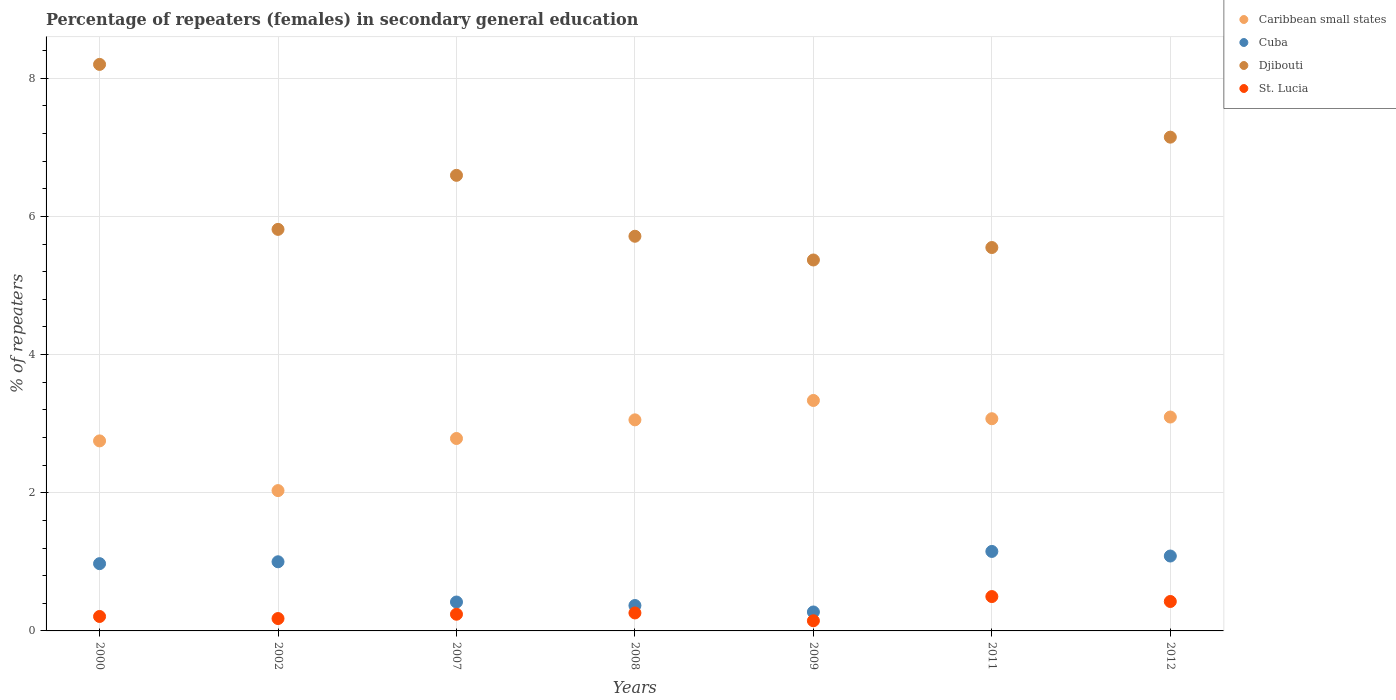Is the number of dotlines equal to the number of legend labels?
Provide a short and direct response. Yes. What is the percentage of female repeaters in St. Lucia in 2011?
Provide a succinct answer. 0.5. Across all years, what is the maximum percentage of female repeaters in Cuba?
Ensure brevity in your answer.  1.15. Across all years, what is the minimum percentage of female repeaters in Caribbean small states?
Give a very brief answer. 2.03. In which year was the percentage of female repeaters in Djibouti maximum?
Your response must be concise. 2000. In which year was the percentage of female repeaters in Djibouti minimum?
Your answer should be compact. 2009. What is the total percentage of female repeaters in Caribbean small states in the graph?
Your response must be concise. 20.13. What is the difference between the percentage of female repeaters in Djibouti in 2000 and that in 2009?
Give a very brief answer. 2.83. What is the difference between the percentage of female repeaters in St. Lucia in 2011 and the percentage of female repeaters in Cuba in 2000?
Offer a terse response. -0.48. What is the average percentage of female repeaters in Djibouti per year?
Your answer should be compact. 6.34. In the year 2011, what is the difference between the percentage of female repeaters in Caribbean small states and percentage of female repeaters in Cuba?
Your answer should be very brief. 1.92. In how many years, is the percentage of female repeaters in Caribbean small states greater than 2.4 %?
Make the answer very short. 6. What is the ratio of the percentage of female repeaters in Djibouti in 2011 to that in 2012?
Your response must be concise. 0.78. Is the difference between the percentage of female repeaters in Caribbean small states in 2009 and 2012 greater than the difference between the percentage of female repeaters in Cuba in 2009 and 2012?
Give a very brief answer. Yes. What is the difference between the highest and the second highest percentage of female repeaters in Cuba?
Keep it short and to the point. 0.07. What is the difference between the highest and the lowest percentage of female repeaters in Cuba?
Give a very brief answer. 0.88. In how many years, is the percentage of female repeaters in Caribbean small states greater than the average percentage of female repeaters in Caribbean small states taken over all years?
Your response must be concise. 4. Is the sum of the percentage of female repeaters in St. Lucia in 2002 and 2012 greater than the maximum percentage of female repeaters in Cuba across all years?
Give a very brief answer. No. Is it the case that in every year, the sum of the percentage of female repeaters in Cuba and percentage of female repeaters in Djibouti  is greater than the percentage of female repeaters in Caribbean small states?
Offer a terse response. Yes. Is the percentage of female repeaters in Cuba strictly greater than the percentage of female repeaters in Djibouti over the years?
Offer a very short reply. No. Is the percentage of female repeaters in Djibouti strictly less than the percentage of female repeaters in Cuba over the years?
Your answer should be very brief. No. What is the difference between two consecutive major ticks on the Y-axis?
Your answer should be very brief. 2. Does the graph contain any zero values?
Make the answer very short. No. Does the graph contain grids?
Offer a very short reply. Yes. How many legend labels are there?
Make the answer very short. 4. How are the legend labels stacked?
Provide a short and direct response. Vertical. What is the title of the graph?
Provide a short and direct response. Percentage of repeaters (females) in secondary general education. What is the label or title of the X-axis?
Offer a very short reply. Years. What is the label or title of the Y-axis?
Provide a short and direct response. % of repeaters. What is the % of repeaters of Caribbean small states in 2000?
Ensure brevity in your answer.  2.75. What is the % of repeaters in Cuba in 2000?
Offer a very short reply. 0.97. What is the % of repeaters of Djibouti in 2000?
Ensure brevity in your answer.  8.2. What is the % of repeaters in St. Lucia in 2000?
Make the answer very short. 0.21. What is the % of repeaters in Caribbean small states in 2002?
Make the answer very short. 2.03. What is the % of repeaters of Cuba in 2002?
Provide a succinct answer. 1. What is the % of repeaters in Djibouti in 2002?
Keep it short and to the point. 5.81. What is the % of repeaters of St. Lucia in 2002?
Keep it short and to the point. 0.18. What is the % of repeaters in Caribbean small states in 2007?
Keep it short and to the point. 2.79. What is the % of repeaters in Cuba in 2007?
Your answer should be compact. 0.42. What is the % of repeaters in Djibouti in 2007?
Give a very brief answer. 6.6. What is the % of repeaters of St. Lucia in 2007?
Give a very brief answer. 0.24. What is the % of repeaters in Caribbean small states in 2008?
Provide a succinct answer. 3.06. What is the % of repeaters of Cuba in 2008?
Your response must be concise. 0.37. What is the % of repeaters in Djibouti in 2008?
Your response must be concise. 5.71. What is the % of repeaters in St. Lucia in 2008?
Your answer should be compact. 0.26. What is the % of repeaters in Caribbean small states in 2009?
Offer a terse response. 3.34. What is the % of repeaters of Cuba in 2009?
Offer a very short reply. 0.27. What is the % of repeaters of Djibouti in 2009?
Offer a very short reply. 5.37. What is the % of repeaters of St. Lucia in 2009?
Your response must be concise. 0.15. What is the % of repeaters in Caribbean small states in 2011?
Keep it short and to the point. 3.07. What is the % of repeaters of Cuba in 2011?
Give a very brief answer. 1.15. What is the % of repeaters of Djibouti in 2011?
Give a very brief answer. 5.55. What is the % of repeaters of St. Lucia in 2011?
Offer a very short reply. 0.5. What is the % of repeaters of Caribbean small states in 2012?
Provide a succinct answer. 3.1. What is the % of repeaters of Cuba in 2012?
Your response must be concise. 1.08. What is the % of repeaters of Djibouti in 2012?
Offer a very short reply. 7.15. What is the % of repeaters in St. Lucia in 2012?
Your answer should be compact. 0.43. Across all years, what is the maximum % of repeaters of Caribbean small states?
Your answer should be very brief. 3.34. Across all years, what is the maximum % of repeaters in Cuba?
Keep it short and to the point. 1.15. Across all years, what is the maximum % of repeaters in Djibouti?
Provide a short and direct response. 8.2. Across all years, what is the maximum % of repeaters of St. Lucia?
Ensure brevity in your answer.  0.5. Across all years, what is the minimum % of repeaters of Caribbean small states?
Your response must be concise. 2.03. Across all years, what is the minimum % of repeaters in Cuba?
Provide a short and direct response. 0.27. Across all years, what is the minimum % of repeaters in Djibouti?
Your answer should be compact. 5.37. Across all years, what is the minimum % of repeaters of St. Lucia?
Provide a short and direct response. 0.15. What is the total % of repeaters in Caribbean small states in the graph?
Offer a very short reply. 20.13. What is the total % of repeaters of Cuba in the graph?
Make the answer very short. 5.27. What is the total % of repeaters in Djibouti in the graph?
Ensure brevity in your answer.  44.39. What is the total % of repeaters in St. Lucia in the graph?
Provide a succinct answer. 1.96. What is the difference between the % of repeaters in Caribbean small states in 2000 and that in 2002?
Make the answer very short. 0.72. What is the difference between the % of repeaters of Cuba in 2000 and that in 2002?
Provide a succinct answer. -0.03. What is the difference between the % of repeaters in Djibouti in 2000 and that in 2002?
Your response must be concise. 2.39. What is the difference between the % of repeaters in St. Lucia in 2000 and that in 2002?
Make the answer very short. 0.03. What is the difference between the % of repeaters of Caribbean small states in 2000 and that in 2007?
Make the answer very short. -0.03. What is the difference between the % of repeaters in Cuba in 2000 and that in 2007?
Make the answer very short. 0.56. What is the difference between the % of repeaters of Djibouti in 2000 and that in 2007?
Provide a short and direct response. 1.61. What is the difference between the % of repeaters in St. Lucia in 2000 and that in 2007?
Make the answer very short. -0.03. What is the difference between the % of repeaters of Caribbean small states in 2000 and that in 2008?
Provide a short and direct response. -0.3. What is the difference between the % of repeaters in Cuba in 2000 and that in 2008?
Make the answer very short. 0.61. What is the difference between the % of repeaters in Djibouti in 2000 and that in 2008?
Keep it short and to the point. 2.49. What is the difference between the % of repeaters of St. Lucia in 2000 and that in 2008?
Offer a very short reply. -0.05. What is the difference between the % of repeaters in Caribbean small states in 2000 and that in 2009?
Ensure brevity in your answer.  -0.59. What is the difference between the % of repeaters in Cuba in 2000 and that in 2009?
Your answer should be very brief. 0.7. What is the difference between the % of repeaters of Djibouti in 2000 and that in 2009?
Your answer should be compact. 2.83. What is the difference between the % of repeaters in St. Lucia in 2000 and that in 2009?
Offer a terse response. 0.06. What is the difference between the % of repeaters in Caribbean small states in 2000 and that in 2011?
Keep it short and to the point. -0.32. What is the difference between the % of repeaters of Cuba in 2000 and that in 2011?
Provide a succinct answer. -0.18. What is the difference between the % of repeaters in Djibouti in 2000 and that in 2011?
Provide a succinct answer. 2.65. What is the difference between the % of repeaters of St. Lucia in 2000 and that in 2011?
Provide a succinct answer. -0.29. What is the difference between the % of repeaters in Caribbean small states in 2000 and that in 2012?
Provide a short and direct response. -0.35. What is the difference between the % of repeaters in Cuba in 2000 and that in 2012?
Your answer should be very brief. -0.11. What is the difference between the % of repeaters in Djibouti in 2000 and that in 2012?
Give a very brief answer. 1.05. What is the difference between the % of repeaters in St. Lucia in 2000 and that in 2012?
Provide a short and direct response. -0.22. What is the difference between the % of repeaters in Caribbean small states in 2002 and that in 2007?
Your answer should be compact. -0.75. What is the difference between the % of repeaters in Cuba in 2002 and that in 2007?
Provide a short and direct response. 0.58. What is the difference between the % of repeaters of Djibouti in 2002 and that in 2007?
Ensure brevity in your answer.  -0.78. What is the difference between the % of repeaters in St. Lucia in 2002 and that in 2007?
Provide a succinct answer. -0.06. What is the difference between the % of repeaters in Caribbean small states in 2002 and that in 2008?
Your answer should be compact. -1.02. What is the difference between the % of repeaters of Cuba in 2002 and that in 2008?
Offer a terse response. 0.63. What is the difference between the % of repeaters of Djibouti in 2002 and that in 2008?
Give a very brief answer. 0.1. What is the difference between the % of repeaters of St. Lucia in 2002 and that in 2008?
Your response must be concise. -0.08. What is the difference between the % of repeaters of Caribbean small states in 2002 and that in 2009?
Give a very brief answer. -1.3. What is the difference between the % of repeaters in Cuba in 2002 and that in 2009?
Provide a short and direct response. 0.73. What is the difference between the % of repeaters of Djibouti in 2002 and that in 2009?
Your answer should be very brief. 0.44. What is the difference between the % of repeaters of St. Lucia in 2002 and that in 2009?
Make the answer very short. 0.03. What is the difference between the % of repeaters in Caribbean small states in 2002 and that in 2011?
Offer a terse response. -1.04. What is the difference between the % of repeaters in Cuba in 2002 and that in 2011?
Your response must be concise. -0.15. What is the difference between the % of repeaters in Djibouti in 2002 and that in 2011?
Make the answer very short. 0.26. What is the difference between the % of repeaters in St. Lucia in 2002 and that in 2011?
Offer a very short reply. -0.32. What is the difference between the % of repeaters of Caribbean small states in 2002 and that in 2012?
Provide a succinct answer. -1.06. What is the difference between the % of repeaters of Cuba in 2002 and that in 2012?
Offer a very short reply. -0.08. What is the difference between the % of repeaters of Djibouti in 2002 and that in 2012?
Provide a short and direct response. -1.34. What is the difference between the % of repeaters of St. Lucia in 2002 and that in 2012?
Give a very brief answer. -0.25. What is the difference between the % of repeaters in Caribbean small states in 2007 and that in 2008?
Your response must be concise. -0.27. What is the difference between the % of repeaters in Cuba in 2007 and that in 2008?
Give a very brief answer. 0.05. What is the difference between the % of repeaters in Djibouti in 2007 and that in 2008?
Offer a terse response. 0.88. What is the difference between the % of repeaters of St. Lucia in 2007 and that in 2008?
Offer a very short reply. -0.02. What is the difference between the % of repeaters of Caribbean small states in 2007 and that in 2009?
Provide a short and direct response. -0.55. What is the difference between the % of repeaters of Cuba in 2007 and that in 2009?
Offer a terse response. 0.14. What is the difference between the % of repeaters in Djibouti in 2007 and that in 2009?
Provide a succinct answer. 1.23. What is the difference between the % of repeaters in St. Lucia in 2007 and that in 2009?
Offer a terse response. 0.09. What is the difference between the % of repeaters of Caribbean small states in 2007 and that in 2011?
Provide a succinct answer. -0.29. What is the difference between the % of repeaters of Cuba in 2007 and that in 2011?
Offer a terse response. -0.73. What is the difference between the % of repeaters in Djibouti in 2007 and that in 2011?
Provide a short and direct response. 1.05. What is the difference between the % of repeaters in St. Lucia in 2007 and that in 2011?
Give a very brief answer. -0.26. What is the difference between the % of repeaters in Caribbean small states in 2007 and that in 2012?
Your answer should be very brief. -0.31. What is the difference between the % of repeaters of Cuba in 2007 and that in 2012?
Offer a terse response. -0.67. What is the difference between the % of repeaters in Djibouti in 2007 and that in 2012?
Give a very brief answer. -0.55. What is the difference between the % of repeaters in St. Lucia in 2007 and that in 2012?
Your answer should be very brief. -0.18. What is the difference between the % of repeaters in Caribbean small states in 2008 and that in 2009?
Your answer should be very brief. -0.28. What is the difference between the % of repeaters in Cuba in 2008 and that in 2009?
Keep it short and to the point. 0.09. What is the difference between the % of repeaters of Djibouti in 2008 and that in 2009?
Your response must be concise. 0.34. What is the difference between the % of repeaters in St. Lucia in 2008 and that in 2009?
Give a very brief answer. 0.11. What is the difference between the % of repeaters of Caribbean small states in 2008 and that in 2011?
Ensure brevity in your answer.  -0.02. What is the difference between the % of repeaters of Cuba in 2008 and that in 2011?
Your answer should be compact. -0.78. What is the difference between the % of repeaters of Djibouti in 2008 and that in 2011?
Your response must be concise. 0.16. What is the difference between the % of repeaters of St. Lucia in 2008 and that in 2011?
Keep it short and to the point. -0.24. What is the difference between the % of repeaters in Caribbean small states in 2008 and that in 2012?
Your response must be concise. -0.04. What is the difference between the % of repeaters in Cuba in 2008 and that in 2012?
Offer a very short reply. -0.72. What is the difference between the % of repeaters in Djibouti in 2008 and that in 2012?
Your answer should be very brief. -1.43. What is the difference between the % of repeaters in St. Lucia in 2008 and that in 2012?
Offer a very short reply. -0.17. What is the difference between the % of repeaters of Caribbean small states in 2009 and that in 2011?
Your response must be concise. 0.26. What is the difference between the % of repeaters in Cuba in 2009 and that in 2011?
Your response must be concise. -0.88. What is the difference between the % of repeaters of Djibouti in 2009 and that in 2011?
Give a very brief answer. -0.18. What is the difference between the % of repeaters of St. Lucia in 2009 and that in 2011?
Give a very brief answer. -0.35. What is the difference between the % of repeaters of Caribbean small states in 2009 and that in 2012?
Your response must be concise. 0.24. What is the difference between the % of repeaters in Cuba in 2009 and that in 2012?
Offer a very short reply. -0.81. What is the difference between the % of repeaters of Djibouti in 2009 and that in 2012?
Keep it short and to the point. -1.78. What is the difference between the % of repeaters of St. Lucia in 2009 and that in 2012?
Your answer should be very brief. -0.28. What is the difference between the % of repeaters in Caribbean small states in 2011 and that in 2012?
Ensure brevity in your answer.  -0.02. What is the difference between the % of repeaters in Cuba in 2011 and that in 2012?
Your response must be concise. 0.07. What is the difference between the % of repeaters of Djibouti in 2011 and that in 2012?
Your answer should be compact. -1.6. What is the difference between the % of repeaters of St. Lucia in 2011 and that in 2012?
Ensure brevity in your answer.  0.07. What is the difference between the % of repeaters in Caribbean small states in 2000 and the % of repeaters in Cuba in 2002?
Offer a terse response. 1.75. What is the difference between the % of repeaters of Caribbean small states in 2000 and the % of repeaters of Djibouti in 2002?
Your response must be concise. -3.06. What is the difference between the % of repeaters of Caribbean small states in 2000 and the % of repeaters of St. Lucia in 2002?
Give a very brief answer. 2.57. What is the difference between the % of repeaters of Cuba in 2000 and the % of repeaters of Djibouti in 2002?
Offer a terse response. -4.84. What is the difference between the % of repeaters of Cuba in 2000 and the % of repeaters of St. Lucia in 2002?
Give a very brief answer. 0.79. What is the difference between the % of repeaters in Djibouti in 2000 and the % of repeaters in St. Lucia in 2002?
Keep it short and to the point. 8.02. What is the difference between the % of repeaters in Caribbean small states in 2000 and the % of repeaters in Cuba in 2007?
Keep it short and to the point. 2.33. What is the difference between the % of repeaters in Caribbean small states in 2000 and the % of repeaters in Djibouti in 2007?
Your answer should be very brief. -3.84. What is the difference between the % of repeaters of Caribbean small states in 2000 and the % of repeaters of St. Lucia in 2007?
Offer a very short reply. 2.51. What is the difference between the % of repeaters in Cuba in 2000 and the % of repeaters in Djibouti in 2007?
Ensure brevity in your answer.  -5.62. What is the difference between the % of repeaters of Cuba in 2000 and the % of repeaters of St. Lucia in 2007?
Keep it short and to the point. 0.73. What is the difference between the % of repeaters of Djibouti in 2000 and the % of repeaters of St. Lucia in 2007?
Make the answer very short. 7.96. What is the difference between the % of repeaters in Caribbean small states in 2000 and the % of repeaters in Cuba in 2008?
Make the answer very short. 2.38. What is the difference between the % of repeaters in Caribbean small states in 2000 and the % of repeaters in Djibouti in 2008?
Provide a succinct answer. -2.96. What is the difference between the % of repeaters of Caribbean small states in 2000 and the % of repeaters of St. Lucia in 2008?
Offer a very short reply. 2.49. What is the difference between the % of repeaters in Cuba in 2000 and the % of repeaters in Djibouti in 2008?
Your answer should be compact. -4.74. What is the difference between the % of repeaters in Cuba in 2000 and the % of repeaters in St. Lucia in 2008?
Give a very brief answer. 0.71. What is the difference between the % of repeaters of Djibouti in 2000 and the % of repeaters of St. Lucia in 2008?
Your answer should be very brief. 7.94. What is the difference between the % of repeaters of Caribbean small states in 2000 and the % of repeaters of Cuba in 2009?
Ensure brevity in your answer.  2.48. What is the difference between the % of repeaters of Caribbean small states in 2000 and the % of repeaters of Djibouti in 2009?
Offer a terse response. -2.62. What is the difference between the % of repeaters in Caribbean small states in 2000 and the % of repeaters in St. Lucia in 2009?
Your answer should be compact. 2.6. What is the difference between the % of repeaters of Cuba in 2000 and the % of repeaters of Djibouti in 2009?
Provide a short and direct response. -4.4. What is the difference between the % of repeaters of Cuba in 2000 and the % of repeaters of St. Lucia in 2009?
Keep it short and to the point. 0.83. What is the difference between the % of repeaters of Djibouti in 2000 and the % of repeaters of St. Lucia in 2009?
Provide a succinct answer. 8.05. What is the difference between the % of repeaters in Caribbean small states in 2000 and the % of repeaters in Cuba in 2011?
Offer a terse response. 1.6. What is the difference between the % of repeaters of Caribbean small states in 2000 and the % of repeaters of Djibouti in 2011?
Offer a very short reply. -2.8. What is the difference between the % of repeaters in Caribbean small states in 2000 and the % of repeaters in St. Lucia in 2011?
Provide a short and direct response. 2.25. What is the difference between the % of repeaters of Cuba in 2000 and the % of repeaters of Djibouti in 2011?
Make the answer very short. -4.58. What is the difference between the % of repeaters in Cuba in 2000 and the % of repeaters in St. Lucia in 2011?
Keep it short and to the point. 0.48. What is the difference between the % of repeaters in Djibouti in 2000 and the % of repeaters in St. Lucia in 2011?
Keep it short and to the point. 7.7. What is the difference between the % of repeaters of Caribbean small states in 2000 and the % of repeaters of Cuba in 2012?
Offer a terse response. 1.67. What is the difference between the % of repeaters in Caribbean small states in 2000 and the % of repeaters in Djibouti in 2012?
Provide a succinct answer. -4.4. What is the difference between the % of repeaters in Caribbean small states in 2000 and the % of repeaters in St. Lucia in 2012?
Offer a very short reply. 2.33. What is the difference between the % of repeaters in Cuba in 2000 and the % of repeaters in Djibouti in 2012?
Keep it short and to the point. -6.17. What is the difference between the % of repeaters of Cuba in 2000 and the % of repeaters of St. Lucia in 2012?
Provide a succinct answer. 0.55. What is the difference between the % of repeaters in Djibouti in 2000 and the % of repeaters in St. Lucia in 2012?
Make the answer very short. 7.78. What is the difference between the % of repeaters in Caribbean small states in 2002 and the % of repeaters in Cuba in 2007?
Give a very brief answer. 1.61. What is the difference between the % of repeaters of Caribbean small states in 2002 and the % of repeaters of Djibouti in 2007?
Provide a succinct answer. -4.56. What is the difference between the % of repeaters of Caribbean small states in 2002 and the % of repeaters of St. Lucia in 2007?
Give a very brief answer. 1.79. What is the difference between the % of repeaters in Cuba in 2002 and the % of repeaters in Djibouti in 2007?
Ensure brevity in your answer.  -5.59. What is the difference between the % of repeaters of Cuba in 2002 and the % of repeaters of St. Lucia in 2007?
Offer a terse response. 0.76. What is the difference between the % of repeaters of Djibouti in 2002 and the % of repeaters of St. Lucia in 2007?
Ensure brevity in your answer.  5.57. What is the difference between the % of repeaters in Caribbean small states in 2002 and the % of repeaters in Cuba in 2008?
Your response must be concise. 1.66. What is the difference between the % of repeaters of Caribbean small states in 2002 and the % of repeaters of Djibouti in 2008?
Offer a very short reply. -3.68. What is the difference between the % of repeaters in Caribbean small states in 2002 and the % of repeaters in St. Lucia in 2008?
Give a very brief answer. 1.77. What is the difference between the % of repeaters in Cuba in 2002 and the % of repeaters in Djibouti in 2008?
Your answer should be compact. -4.71. What is the difference between the % of repeaters in Cuba in 2002 and the % of repeaters in St. Lucia in 2008?
Keep it short and to the point. 0.74. What is the difference between the % of repeaters in Djibouti in 2002 and the % of repeaters in St. Lucia in 2008?
Offer a terse response. 5.55. What is the difference between the % of repeaters of Caribbean small states in 2002 and the % of repeaters of Cuba in 2009?
Make the answer very short. 1.76. What is the difference between the % of repeaters in Caribbean small states in 2002 and the % of repeaters in Djibouti in 2009?
Make the answer very short. -3.34. What is the difference between the % of repeaters of Caribbean small states in 2002 and the % of repeaters of St. Lucia in 2009?
Your answer should be compact. 1.88. What is the difference between the % of repeaters in Cuba in 2002 and the % of repeaters in Djibouti in 2009?
Keep it short and to the point. -4.37. What is the difference between the % of repeaters in Cuba in 2002 and the % of repeaters in St. Lucia in 2009?
Offer a terse response. 0.85. What is the difference between the % of repeaters in Djibouti in 2002 and the % of repeaters in St. Lucia in 2009?
Provide a succinct answer. 5.67. What is the difference between the % of repeaters of Caribbean small states in 2002 and the % of repeaters of Cuba in 2011?
Provide a succinct answer. 0.88. What is the difference between the % of repeaters of Caribbean small states in 2002 and the % of repeaters of Djibouti in 2011?
Offer a terse response. -3.52. What is the difference between the % of repeaters in Caribbean small states in 2002 and the % of repeaters in St. Lucia in 2011?
Keep it short and to the point. 1.53. What is the difference between the % of repeaters of Cuba in 2002 and the % of repeaters of Djibouti in 2011?
Your answer should be very brief. -4.55. What is the difference between the % of repeaters in Cuba in 2002 and the % of repeaters in St. Lucia in 2011?
Offer a very short reply. 0.5. What is the difference between the % of repeaters in Djibouti in 2002 and the % of repeaters in St. Lucia in 2011?
Provide a short and direct response. 5.32. What is the difference between the % of repeaters of Caribbean small states in 2002 and the % of repeaters of Cuba in 2012?
Ensure brevity in your answer.  0.95. What is the difference between the % of repeaters of Caribbean small states in 2002 and the % of repeaters of Djibouti in 2012?
Your answer should be very brief. -5.12. What is the difference between the % of repeaters in Caribbean small states in 2002 and the % of repeaters in St. Lucia in 2012?
Give a very brief answer. 1.61. What is the difference between the % of repeaters of Cuba in 2002 and the % of repeaters of Djibouti in 2012?
Ensure brevity in your answer.  -6.15. What is the difference between the % of repeaters of Cuba in 2002 and the % of repeaters of St. Lucia in 2012?
Your answer should be very brief. 0.57. What is the difference between the % of repeaters in Djibouti in 2002 and the % of repeaters in St. Lucia in 2012?
Give a very brief answer. 5.39. What is the difference between the % of repeaters in Caribbean small states in 2007 and the % of repeaters in Cuba in 2008?
Provide a succinct answer. 2.42. What is the difference between the % of repeaters of Caribbean small states in 2007 and the % of repeaters of Djibouti in 2008?
Your answer should be very brief. -2.93. What is the difference between the % of repeaters in Caribbean small states in 2007 and the % of repeaters in St. Lucia in 2008?
Keep it short and to the point. 2.53. What is the difference between the % of repeaters of Cuba in 2007 and the % of repeaters of Djibouti in 2008?
Your response must be concise. -5.3. What is the difference between the % of repeaters in Cuba in 2007 and the % of repeaters in St. Lucia in 2008?
Offer a very short reply. 0.16. What is the difference between the % of repeaters of Djibouti in 2007 and the % of repeaters of St. Lucia in 2008?
Offer a very short reply. 6.34. What is the difference between the % of repeaters of Caribbean small states in 2007 and the % of repeaters of Cuba in 2009?
Make the answer very short. 2.51. What is the difference between the % of repeaters of Caribbean small states in 2007 and the % of repeaters of Djibouti in 2009?
Provide a short and direct response. -2.58. What is the difference between the % of repeaters of Caribbean small states in 2007 and the % of repeaters of St. Lucia in 2009?
Keep it short and to the point. 2.64. What is the difference between the % of repeaters of Cuba in 2007 and the % of repeaters of Djibouti in 2009?
Ensure brevity in your answer.  -4.95. What is the difference between the % of repeaters in Cuba in 2007 and the % of repeaters in St. Lucia in 2009?
Provide a short and direct response. 0.27. What is the difference between the % of repeaters of Djibouti in 2007 and the % of repeaters of St. Lucia in 2009?
Offer a terse response. 6.45. What is the difference between the % of repeaters in Caribbean small states in 2007 and the % of repeaters in Cuba in 2011?
Offer a terse response. 1.64. What is the difference between the % of repeaters of Caribbean small states in 2007 and the % of repeaters of Djibouti in 2011?
Provide a succinct answer. -2.76. What is the difference between the % of repeaters in Caribbean small states in 2007 and the % of repeaters in St. Lucia in 2011?
Ensure brevity in your answer.  2.29. What is the difference between the % of repeaters in Cuba in 2007 and the % of repeaters in Djibouti in 2011?
Your response must be concise. -5.13. What is the difference between the % of repeaters of Cuba in 2007 and the % of repeaters of St. Lucia in 2011?
Your answer should be compact. -0.08. What is the difference between the % of repeaters of Djibouti in 2007 and the % of repeaters of St. Lucia in 2011?
Your response must be concise. 6.1. What is the difference between the % of repeaters of Caribbean small states in 2007 and the % of repeaters of Cuba in 2012?
Give a very brief answer. 1.7. What is the difference between the % of repeaters of Caribbean small states in 2007 and the % of repeaters of Djibouti in 2012?
Offer a terse response. -4.36. What is the difference between the % of repeaters of Caribbean small states in 2007 and the % of repeaters of St. Lucia in 2012?
Provide a succinct answer. 2.36. What is the difference between the % of repeaters of Cuba in 2007 and the % of repeaters of Djibouti in 2012?
Provide a succinct answer. -6.73. What is the difference between the % of repeaters in Cuba in 2007 and the % of repeaters in St. Lucia in 2012?
Your answer should be compact. -0.01. What is the difference between the % of repeaters of Djibouti in 2007 and the % of repeaters of St. Lucia in 2012?
Provide a succinct answer. 6.17. What is the difference between the % of repeaters in Caribbean small states in 2008 and the % of repeaters in Cuba in 2009?
Your answer should be compact. 2.78. What is the difference between the % of repeaters in Caribbean small states in 2008 and the % of repeaters in Djibouti in 2009?
Keep it short and to the point. -2.31. What is the difference between the % of repeaters of Caribbean small states in 2008 and the % of repeaters of St. Lucia in 2009?
Give a very brief answer. 2.91. What is the difference between the % of repeaters of Cuba in 2008 and the % of repeaters of Djibouti in 2009?
Ensure brevity in your answer.  -5. What is the difference between the % of repeaters in Cuba in 2008 and the % of repeaters in St. Lucia in 2009?
Make the answer very short. 0.22. What is the difference between the % of repeaters of Djibouti in 2008 and the % of repeaters of St. Lucia in 2009?
Offer a terse response. 5.57. What is the difference between the % of repeaters in Caribbean small states in 2008 and the % of repeaters in Cuba in 2011?
Provide a succinct answer. 1.9. What is the difference between the % of repeaters of Caribbean small states in 2008 and the % of repeaters of Djibouti in 2011?
Provide a short and direct response. -2.49. What is the difference between the % of repeaters of Caribbean small states in 2008 and the % of repeaters of St. Lucia in 2011?
Offer a very short reply. 2.56. What is the difference between the % of repeaters of Cuba in 2008 and the % of repeaters of Djibouti in 2011?
Keep it short and to the point. -5.18. What is the difference between the % of repeaters of Cuba in 2008 and the % of repeaters of St. Lucia in 2011?
Your answer should be compact. -0.13. What is the difference between the % of repeaters in Djibouti in 2008 and the % of repeaters in St. Lucia in 2011?
Offer a terse response. 5.22. What is the difference between the % of repeaters of Caribbean small states in 2008 and the % of repeaters of Cuba in 2012?
Offer a very short reply. 1.97. What is the difference between the % of repeaters of Caribbean small states in 2008 and the % of repeaters of Djibouti in 2012?
Provide a succinct answer. -4.09. What is the difference between the % of repeaters of Caribbean small states in 2008 and the % of repeaters of St. Lucia in 2012?
Offer a very short reply. 2.63. What is the difference between the % of repeaters of Cuba in 2008 and the % of repeaters of Djibouti in 2012?
Keep it short and to the point. -6.78. What is the difference between the % of repeaters in Cuba in 2008 and the % of repeaters in St. Lucia in 2012?
Your answer should be compact. -0.06. What is the difference between the % of repeaters of Djibouti in 2008 and the % of repeaters of St. Lucia in 2012?
Make the answer very short. 5.29. What is the difference between the % of repeaters of Caribbean small states in 2009 and the % of repeaters of Cuba in 2011?
Your answer should be very brief. 2.19. What is the difference between the % of repeaters of Caribbean small states in 2009 and the % of repeaters of Djibouti in 2011?
Provide a short and direct response. -2.21. What is the difference between the % of repeaters of Caribbean small states in 2009 and the % of repeaters of St. Lucia in 2011?
Your answer should be very brief. 2.84. What is the difference between the % of repeaters of Cuba in 2009 and the % of repeaters of Djibouti in 2011?
Make the answer very short. -5.28. What is the difference between the % of repeaters in Cuba in 2009 and the % of repeaters in St. Lucia in 2011?
Your answer should be very brief. -0.22. What is the difference between the % of repeaters of Djibouti in 2009 and the % of repeaters of St. Lucia in 2011?
Provide a short and direct response. 4.87. What is the difference between the % of repeaters of Caribbean small states in 2009 and the % of repeaters of Cuba in 2012?
Offer a very short reply. 2.25. What is the difference between the % of repeaters in Caribbean small states in 2009 and the % of repeaters in Djibouti in 2012?
Your answer should be compact. -3.81. What is the difference between the % of repeaters of Caribbean small states in 2009 and the % of repeaters of St. Lucia in 2012?
Your response must be concise. 2.91. What is the difference between the % of repeaters in Cuba in 2009 and the % of repeaters in Djibouti in 2012?
Offer a very short reply. -6.87. What is the difference between the % of repeaters in Cuba in 2009 and the % of repeaters in St. Lucia in 2012?
Your answer should be very brief. -0.15. What is the difference between the % of repeaters of Djibouti in 2009 and the % of repeaters of St. Lucia in 2012?
Make the answer very short. 4.94. What is the difference between the % of repeaters of Caribbean small states in 2011 and the % of repeaters of Cuba in 2012?
Your answer should be compact. 1.99. What is the difference between the % of repeaters in Caribbean small states in 2011 and the % of repeaters in Djibouti in 2012?
Your answer should be very brief. -4.08. What is the difference between the % of repeaters of Caribbean small states in 2011 and the % of repeaters of St. Lucia in 2012?
Make the answer very short. 2.65. What is the difference between the % of repeaters of Cuba in 2011 and the % of repeaters of Djibouti in 2012?
Give a very brief answer. -6. What is the difference between the % of repeaters in Cuba in 2011 and the % of repeaters in St. Lucia in 2012?
Your response must be concise. 0.72. What is the difference between the % of repeaters of Djibouti in 2011 and the % of repeaters of St. Lucia in 2012?
Ensure brevity in your answer.  5.12. What is the average % of repeaters of Caribbean small states per year?
Make the answer very short. 2.88. What is the average % of repeaters in Cuba per year?
Keep it short and to the point. 0.75. What is the average % of repeaters of Djibouti per year?
Your answer should be very brief. 6.34. What is the average % of repeaters in St. Lucia per year?
Ensure brevity in your answer.  0.28. In the year 2000, what is the difference between the % of repeaters of Caribbean small states and % of repeaters of Cuba?
Your answer should be compact. 1.78. In the year 2000, what is the difference between the % of repeaters of Caribbean small states and % of repeaters of Djibouti?
Provide a succinct answer. -5.45. In the year 2000, what is the difference between the % of repeaters in Caribbean small states and % of repeaters in St. Lucia?
Your response must be concise. 2.54. In the year 2000, what is the difference between the % of repeaters in Cuba and % of repeaters in Djibouti?
Ensure brevity in your answer.  -7.23. In the year 2000, what is the difference between the % of repeaters of Cuba and % of repeaters of St. Lucia?
Keep it short and to the point. 0.76. In the year 2000, what is the difference between the % of repeaters of Djibouti and % of repeaters of St. Lucia?
Your answer should be compact. 7.99. In the year 2002, what is the difference between the % of repeaters in Caribbean small states and % of repeaters in Cuba?
Ensure brevity in your answer.  1.03. In the year 2002, what is the difference between the % of repeaters in Caribbean small states and % of repeaters in Djibouti?
Provide a short and direct response. -3.78. In the year 2002, what is the difference between the % of repeaters in Caribbean small states and % of repeaters in St. Lucia?
Your response must be concise. 1.85. In the year 2002, what is the difference between the % of repeaters of Cuba and % of repeaters of Djibouti?
Provide a short and direct response. -4.81. In the year 2002, what is the difference between the % of repeaters in Cuba and % of repeaters in St. Lucia?
Your response must be concise. 0.82. In the year 2002, what is the difference between the % of repeaters in Djibouti and % of repeaters in St. Lucia?
Offer a terse response. 5.63. In the year 2007, what is the difference between the % of repeaters of Caribbean small states and % of repeaters of Cuba?
Give a very brief answer. 2.37. In the year 2007, what is the difference between the % of repeaters of Caribbean small states and % of repeaters of Djibouti?
Give a very brief answer. -3.81. In the year 2007, what is the difference between the % of repeaters of Caribbean small states and % of repeaters of St. Lucia?
Ensure brevity in your answer.  2.54. In the year 2007, what is the difference between the % of repeaters in Cuba and % of repeaters in Djibouti?
Your answer should be very brief. -6.18. In the year 2007, what is the difference between the % of repeaters of Cuba and % of repeaters of St. Lucia?
Give a very brief answer. 0.18. In the year 2007, what is the difference between the % of repeaters in Djibouti and % of repeaters in St. Lucia?
Keep it short and to the point. 6.35. In the year 2008, what is the difference between the % of repeaters in Caribbean small states and % of repeaters in Cuba?
Offer a terse response. 2.69. In the year 2008, what is the difference between the % of repeaters of Caribbean small states and % of repeaters of Djibouti?
Provide a succinct answer. -2.66. In the year 2008, what is the difference between the % of repeaters of Caribbean small states and % of repeaters of St. Lucia?
Your answer should be very brief. 2.8. In the year 2008, what is the difference between the % of repeaters in Cuba and % of repeaters in Djibouti?
Make the answer very short. -5.35. In the year 2008, what is the difference between the % of repeaters in Cuba and % of repeaters in St. Lucia?
Your answer should be very brief. 0.11. In the year 2008, what is the difference between the % of repeaters of Djibouti and % of repeaters of St. Lucia?
Give a very brief answer. 5.45. In the year 2009, what is the difference between the % of repeaters in Caribbean small states and % of repeaters in Cuba?
Your answer should be very brief. 3.06. In the year 2009, what is the difference between the % of repeaters of Caribbean small states and % of repeaters of Djibouti?
Provide a succinct answer. -2.03. In the year 2009, what is the difference between the % of repeaters in Caribbean small states and % of repeaters in St. Lucia?
Your response must be concise. 3.19. In the year 2009, what is the difference between the % of repeaters of Cuba and % of repeaters of Djibouti?
Your response must be concise. -5.1. In the year 2009, what is the difference between the % of repeaters of Cuba and % of repeaters of St. Lucia?
Provide a short and direct response. 0.13. In the year 2009, what is the difference between the % of repeaters of Djibouti and % of repeaters of St. Lucia?
Offer a very short reply. 5.22. In the year 2011, what is the difference between the % of repeaters in Caribbean small states and % of repeaters in Cuba?
Offer a very short reply. 1.92. In the year 2011, what is the difference between the % of repeaters in Caribbean small states and % of repeaters in Djibouti?
Offer a terse response. -2.48. In the year 2011, what is the difference between the % of repeaters in Caribbean small states and % of repeaters in St. Lucia?
Make the answer very short. 2.57. In the year 2011, what is the difference between the % of repeaters of Cuba and % of repeaters of Djibouti?
Your answer should be very brief. -4.4. In the year 2011, what is the difference between the % of repeaters in Cuba and % of repeaters in St. Lucia?
Your response must be concise. 0.65. In the year 2011, what is the difference between the % of repeaters of Djibouti and % of repeaters of St. Lucia?
Your response must be concise. 5.05. In the year 2012, what is the difference between the % of repeaters of Caribbean small states and % of repeaters of Cuba?
Your answer should be compact. 2.01. In the year 2012, what is the difference between the % of repeaters of Caribbean small states and % of repeaters of Djibouti?
Provide a succinct answer. -4.05. In the year 2012, what is the difference between the % of repeaters in Caribbean small states and % of repeaters in St. Lucia?
Provide a short and direct response. 2.67. In the year 2012, what is the difference between the % of repeaters of Cuba and % of repeaters of Djibouti?
Offer a very short reply. -6.06. In the year 2012, what is the difference between the % of repeaters in Cuba and % of repeaters in St. Lucia?
Keep it short and to the point. 0.66. In the year 2012, what is the difference between the % of repeaters of Djibouti and % of repeaters of St. Lucia?
Provide a succinct answer. 6.72. What is the ratio of the % of repeaters of Caribbean small states in 2000 to that in 2002?
Your answer should be compact. 1.35. What is the ratio of the % of repeaters in Cuba in 2000 to that in 2002?
Ensure brevity in your answer.  0.97. What is the ratio of the % of repeaters of Djibouti in 2000 to that in 2002?
Provide a short and direct response. 1.41. What is the ratio of the % of repeaters in St. Lucia in 2000 to that in 2002?
Make the answer very short. 1.17. What is the ratio of the % of repeaters of Caribbean small states in 2000 to that in 2007?
Give a very brief answer. 0.99. What is the ratio of the % of repeaters in Cuba in 2000 to that in 2007?
Provide a short and direct response. 2.33. What is the ratio of the % of repeaters of Djibouti in 2000 to that in 2007?
Offer a terse response. 1.24. What is the ratio of the % of repeaters in St. Lucia in 2000 to that in 2007?
Your answer should be very brief. 0.87. What is the ratio of the % of repeaters of Caribbean small states in 2000 to that in 2008?
Your response must be concise. 0.9. What is the ratio of the % of repeaters of Cuba in 2000 to that in 2008?
Provide a succinct answer. 2.65. What is the ratio of the % of repeaters of Djibouti in 2000 to that in 2008?
Provide a succinct answer. 1.44. What is the ratio of the % of repeaters in St. Lucia in 2000 to that in 2008?
Keep it short and to the point. 0.8. What is the ratio of the % of repeaters in Caribbean small states in 2000 to that in 2009?
Make the answer very short. 0.82. What is the ratio of the % of repeaters of Cuba in 2000 to that in 2009?
Keep it short and to the point. 3.55. What is the ratio of the % of repeaters of Djibouti in 2000 to that in 2009?
Offer a very short reply. 1.53. What is the ratio of the % of repeaters of St. Lucia in 2000 to that in 2009?
Keep it short and to the point. 1.42. What is the ratio of the % of repeaters of Caribbean small states in 2000 to that in 2011?
Ensure brevity in your answer.  0.9. What is the ratio of the % of repeaters of Cuba in 2000 to that in 2011?
Provide a succinct answer. 0.85. What is the ratio of the % of repeaters of Djibouti in 2000 to that in 2011?
Provide a succinct answer. 1.48. What is the ratio of the % of repeaters of St. Lucia in 2000 to that in 2011?
Keep it short and to the point. 0.42. What is the ratio of the % of repeaters in Caribbean small states in 2000 to that in 2012?
Keep it short and to the point. 0.89. What is the ratio of the % of repeaters in Cuba in 2000 to that in 2012?
Offer a terse response. 0.9. What is the ratio of the % of repeaters of Djibouti in 2000 to that in 2012?
Provide a short and direct response. 1.15. What is the ratio of the % of repeaters in St. Lucia in 2000 to that in 2012?
Keep it short and to the point. 0.49. What is the ratio of the % of repeaters in Caribbean small states in 2002 to that in 2007?
Provide a succinct answer. 0.73. What is the ratio of the % of repeaters of Cuba in 2002 to that in 2007?
Provide a succinct answer. 2.39. What is the ratio of the % of repeaters of Djibouti in 2002 to that in 2007?
Offer a very short reply. 0.88. What is the ratio of the % of repeaters of St. Lucia in 2002 to that in 2007?
Offer a very short reply. 0.74. What is the ratio of the % of repeaters in Caribbean small states in 2002 to that in 2008?
Your answer should be compact. 0.66. What is the ratio of the % of repeaters of Cuba in 2002 to that in 2008?
Your answer should be very brief. 2.72. What is the ratio of the % of repeaters in Djibouti in 2002 to that in 2008?
Provide a succinct answer. 1.02. What is the ratio of the % of repeaters of St. Lucia in 2002 to that in 2008?
Ensure brevity in your answer.  0.69. What is the ratio of the % of repeaters of Caribbean small states in 2002 to that in 2009?
Offer a terse response. 0.61. What is the ratio of the % of repeaters of Cuba in 2002 to that in 2009?
Offer a terse response. 3.65. What is the ratio of the % of repeaters of Djibouti in 2002 to that in 2009?
Give a very brief answer. 1.08. What is the ratio of the % of repeaters of St. Lucia in 2002 to that in 2009?
Make the answer very short. 1.22. What is the ratio of the % of repeaters of Caribbean small states in 2002 to that in 2011?
Make the answer very short. 0.66. What is the ratio of the % of repeaters of Cuba in 2002 to that in 2011?
Provide a succinct answer. 0.87. What is the ratio of the % of repeaters of Djibouti in 2002 to that in 2011?
Make the answer very short. 1.05. What is the ratio of the % of repeaters in St. Lucia in 2002 to that in 2011?
Offer a very short reply. 0.36. What is the ratio of the % of repeaters in Caribbean small states in 2002 to that in 2012?
Your answer should be compact. 0.66. What is the ratio of the % of repeaters in Cuba in 2002 to that in 2012?
Make the answer very short. 0.92. What is the ratio of the % of repeaters of Djibouti in 2002 to that in 2012?
Make the answer very short. 0.81. What is the ratio of the % of repeaters of St. Lucia in 2002 to that in 2012?
Provide a short and direct response. 0.42. What is the ratio of the % of repeaters of Caribbean small states in 2007 to that in 2008?
Your response must be concise. 0.91. What is the ratio of the % of repeaters in Cuba in 2007 to that in 2008?
Your answer should be very brief. 1.14. What is the ratio of the % of repeaters in Djibouti in 2007 to that in 2008?
Provide a succinct answer. 1.15. What is the ratio of the % of repeaters of St. Lucia in 2007 to that in 2008?
Keep it short and to the point. 0.93. What is the ratio of the % of repeaters in Caribbean small states in 2007 to that in 2009?
Offer a very short reply. 0.83. What is the ratio of the % of repeaters of Cuba in 2007 to that in 2009?
Make the answer very short. 1.52. What is the ratio of the % of repeaters in Djibouti in 2007 to that in 2009?
Offer a terse response. 1.23. What is the ratio of the % of repeaters of St. Lucia in 2007 to that in 2009?
Provide a short and direct response. 1.64. What is the ratio of the % of repeaters in Caribbean small states in 2007 to that in 2011?
Offer a terse response. 0.91. What is the ratio of the % of repeaters in Cuba in 2007 to that in 2011?
Your answer should be very brief. 0.36. What is the ratio of the % of repeaters of Djibouti in 2007 to that in 2011?
Your answer should be compact. 1.19. What is the ratio of the % of repeaters in St. Lucia in 2007 to that in 2011?
Provide a short and direct response. 0.49. What is the ratio of the % of repeaters in Caribbean small states in 2007 to that in 2012?
Your answer should be very brief. 0.9. What is the ratio of the % of repeaters in Cuba in 2007 to that in 2012?
Your response must be concise. 0.39. What is the ratio of the % of repeaters of Djibouti in 2007 to that in 2012?
Make the answer very short. 0.92. What is the ratio of the % of repeaters of St. Lucia in 2007 to that in 2012?
Make the answer very short. 0.57. What is the ratio of the % of repeaters of Caribbean small states in 2008 to that in 2009?
Your answer should be very brief. 0.92. What is the ratio of the % of repeaters of Cuba in 2008 to that in 2009?
Provide a short and direct response. 1.34. What is the ratio of the % of repeaters in Djibouti in 2008 to that in 2009?
Offer a terse response. 1.06. What is the ratio of the % of repeaters of St. Lucia in 2008 to that in 2009?
Offer a terse response. 1.77. What is the ratio of the % of repeaters of Caribbean small states in 2008 to that in 2011?
Your answer should be compact. 0.99. What is the ratio of the % of repeaters of Cuba in 2008 to that in 2011?
Provide a succinct answer. 0.32. What is the ratio of the % of repeaters of Djibouti in 2008 to that in 2011?
Offer a very short reply. 1.03. What is the ratio of the % of repeaters of St. Lucia in 2008 to that in 2011?
Make the answer very short. 0.52. What is the ratio of the % of repeaters in Caribbean small states in 2008 to that in 2012?
Make the answer very short. 0.99. What is the ratio of the % of repeaters of Cuba in 2008 to that in 2012?
Provide a short and direct response. 0.34. What is the ratio of the % of repeaters of Djibouti in 2008 to that in 2012?
Ensure brevity in your answer.  0.8. What is the ratio of the % of repeaters of St. Lucia in 2008 to that in 2012?
Offer a very short reply. 0.61. What is the ratio of the % of repeaters of Caribbean small states in 2009 to that in 2011?
Provide a succinct answer. 1.09. What is the ratio of the % of repeaters in Cuba in 2009 to that in 2011?
Provide a succinct answer. 0.24. What is the ratio of the % of repeaters of Djibouti in 2009 to that in 2011?
Your answer should be compact. 0.97. What is the ratio of the % of repeaters in St. Lucia in 2009 to that in 2011?
Provide a short and direct response. 0.3. What is the ratio of the % of repeaters in Caribbean small states in 2009 to that in 2012?
Make the answer very short. 1.08. What is the ratio of the % of repeaters of Cuba in 2009 to that in 2012?
Offer a terse response. 0.25. What is the ratio of the % of repeaters of Djibouti in 2009 to that in 2012?
Offer a terse response. 0.75. What is the ratio of the % of repeaters of St. Lucia in 2009 to that in 2012?
Your response must be concise. 0.35. What is the ratio of the % of repeaters in Caribbean small states in 2011 to that in 2012?
Your response must be concise. 0.99. What is the ratio of the % of repeaters in Cuba in 2011 to that in 2012?
Ensure brevity in your answer.  1.06. What is the ratio of the % of repeaters of Djibouti in 2011 to that in 2012?
Your answer should be very brief. 0.78. What is the ratio of the % of repeaters of St. Lucia in 2011 to that in 2012?
Your answer should be very brief. 1.17. What is the difference between the highest and the second highest % of repeaters of Caribbean small states?
Ensure brevity in your answer.  0.24. What is the difference between the highest and the second highest % of repeaters of Cuba?
Make the answer very short. 0.07. What is the difference between the highest and the second highest % of repeaters in Djibouti?
Offer a terse response. 1.05. What is the difference between the highest and the second highest % of repeaters in St. Lucia?
Keep it short and to the point. 0.07. What is the difference between the highest and the lowest % of repeaters in Caribbean small states?
Your answer should be compact. 1.3. What is the difference between the highest and the lowest % of repeaters of Cuba?
Keep it short and to the point. 0.88. What is the difference between the highest and the lowest % of repeaters of Djibouti?
Make the answer very short. 2.83. What is the difference between the highest and the lowest % of repeaters in St. Lucia?
Offer a terse response. 0.35. 